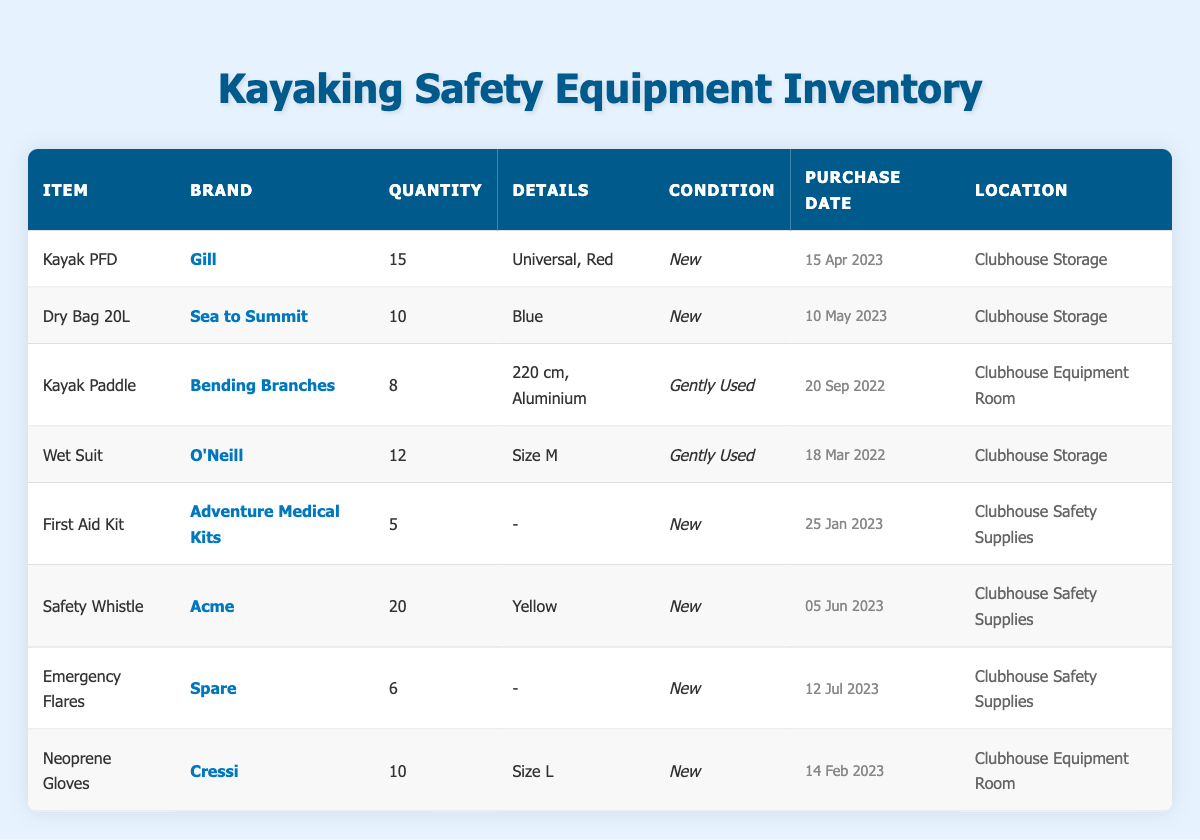What is the total quantity of Safety Whistles available? The inventory lists 20 Safety Whistles in the table under the corresponding row. Therefore, the total quantity is directly stated as 20.
Answer: 20 How many items in the inventory have the condition listed as 'New'? By reviewing each row in the table, we count the items with a condition of 'New'. These items are the Kayak PFD, Dry Bag 20L, First Aid Kit, Safety Whistle, Emergency Flares, and Neoprene Gloves, which totals to 6 items.
Answer: 6 Is there any Kayak Paddle available in the inventory? The table includes a row for Kayak Paddle, indicating 8 units are available in gently used condition. Thus, the answer is yes.
Answer: Yes Which item has the most quantity in stock? By comparing the quantity values listed beside each item, the Safety Whistle has 20 units, which is more than any other item in the table. Therefore, it is the item with the most stock.
Answer: Safety Whistle What is the average purchase date of the items in the inventory? First, we convert the purchase dates into a numerical format (e.g., days since a reference date). Then we compute the average of these dates. The purchases were made on 2022-03-18, 2022-09-20, 2023-01-25, 2023-02-14, 2023-04-15, 2023-05-10, 2023-06-05, and 2023-07-12, amounting to 8 dates. Their average date is calculated as 2023-04-05.
Answer: 05 April 2023 How many pieces of equipment are stored in the 'Clubhouse Safety Supplies'? The inventory lists two items under 'Clubhouse Safety Supplies': the First Aid Kit and the Emergency Flares, making a total of 2 pieces of equipment in that location.
Answer: 2 